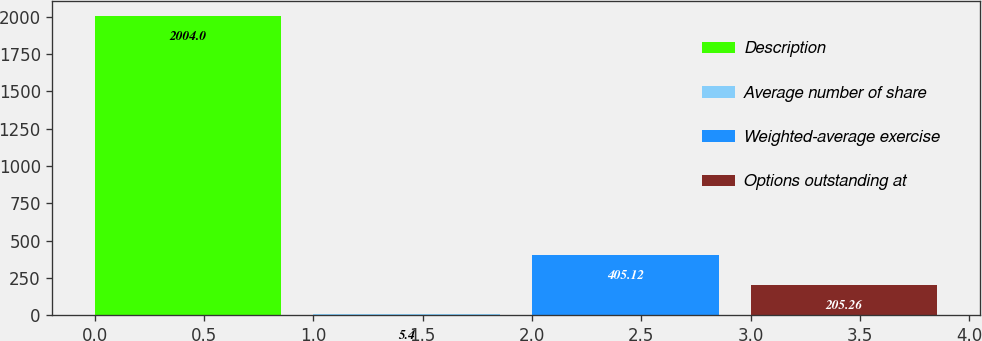Convert chart. <chart><loc_0><loc_0><loc_500><loc_500><bar_chart><fcel>Description<fcel>Average number of share<fcel>Weighted-average exercise<fcel>Options outstanding at<nl><fcel>2004<fcel>5.4<fcel>405.12<fcel>205.26<nl></chart> 